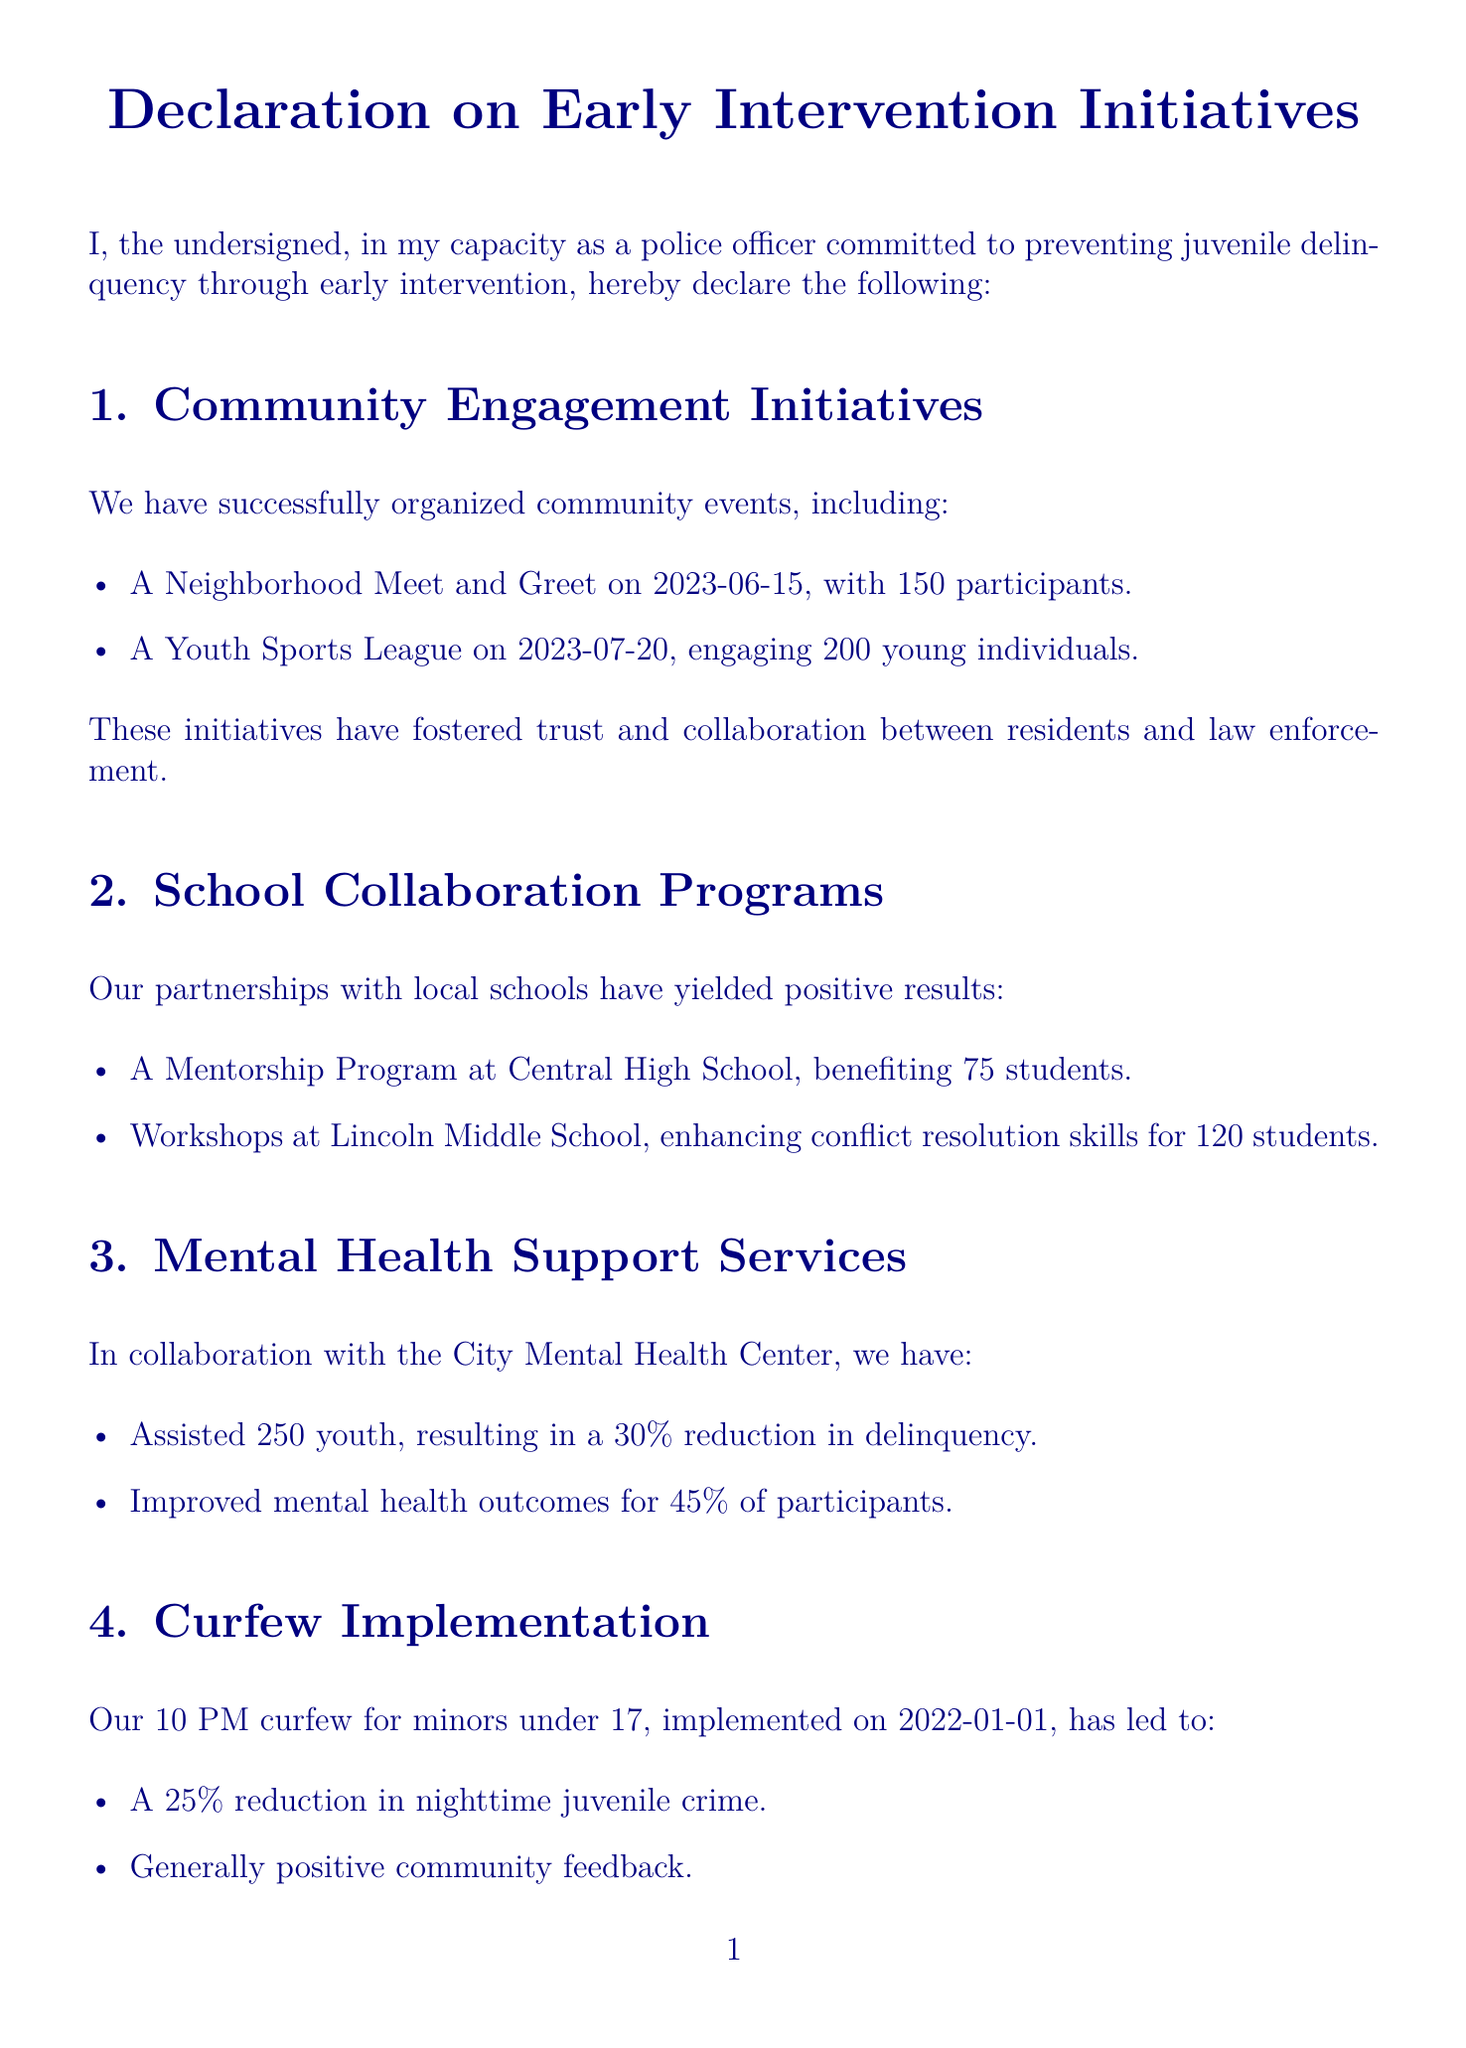What is the date of the Neighborhood Meet and Greet? The document states that the Neighborhood Meet and Greet was organized on 2023-06-15.
Answer: 2023-06-15 How many participants engaged in the Youth Sports League? The Youth Sports League engaged 200 young individuals, as mentioned in the document.
Answer: 200 What is the reduction percentage in delinquency from mental health support services? The document reports a 30% reduction in delinquency from the mental health support services offered.
Answer: 30% What time is the curfew for minors under 17? The document indicates that the curfew for minors is set at 10 PM.
Answer: 10 PM How many officers were trained in early intervention techniques? According to the document, 50 officers were trained in early intervention techniques.
Answer: 50 What was the outcome for participants in mental health services? The document states that 45% of participants improved their mental health outcomes.
Answer: 45% What was the implementation date of the curfew? The document specifies that the curfew was implemented on 2022-01-01.
Answer: 2022-01-01 What type of program was held at Central High School? The document mentions a Mentorship Program at Central High School.
Answer: Mentorship Program How much was the increase in successful early intervention cases? The document notes a 40% increase in successful early intervention cases.
Answer: 40% 